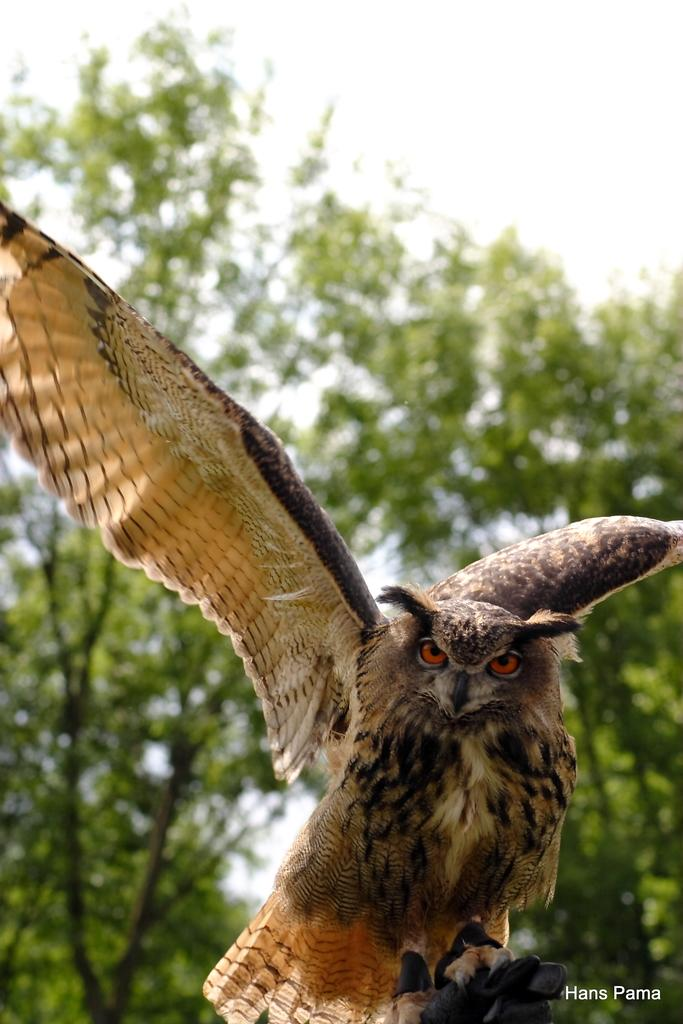What animal is the main subject of the image? There is an eagle in the image. What type of vegetation can be seen in the background of the image? There are green color trees in the background of the image. What is visible at the top of the image? The sky is visible at the top of the image. How many quarters are visible on the eagle's wings in the image? There are no quarters visible on the eagle's wings in the image. What type of police vehicle can be seen in the image? There is no police vehicle present in the image. 